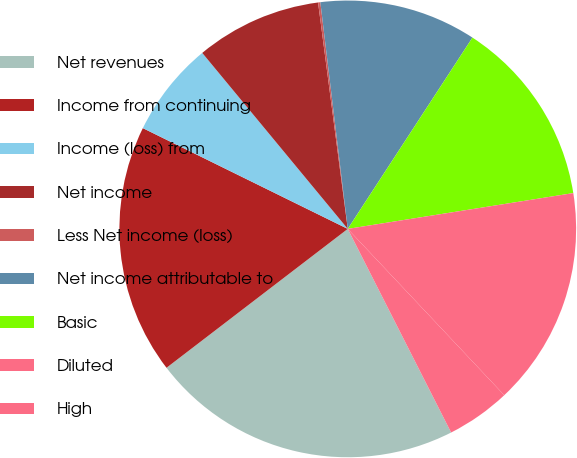Convert chart to OTSL. <chart><loc_0><loc_0><loc_500><loc_500><pie_chart><fcel>Net revenues<fcel>Income from continuing<fcel>Income (loss) from<fcel>Net income<fcel>Less Net income (loss)<fcel>Net income attributable to<fcel>Basic<fcel>Diluted<fcel>High<nl><fcel>22.07%<fcel>17.68%<fcel>6.73%<fcel>8.92%<fcel>0.16%<fcel>11.11%<fcel>13.3%<fcel>15.49%<fcel>4.54%<nl></chart> 